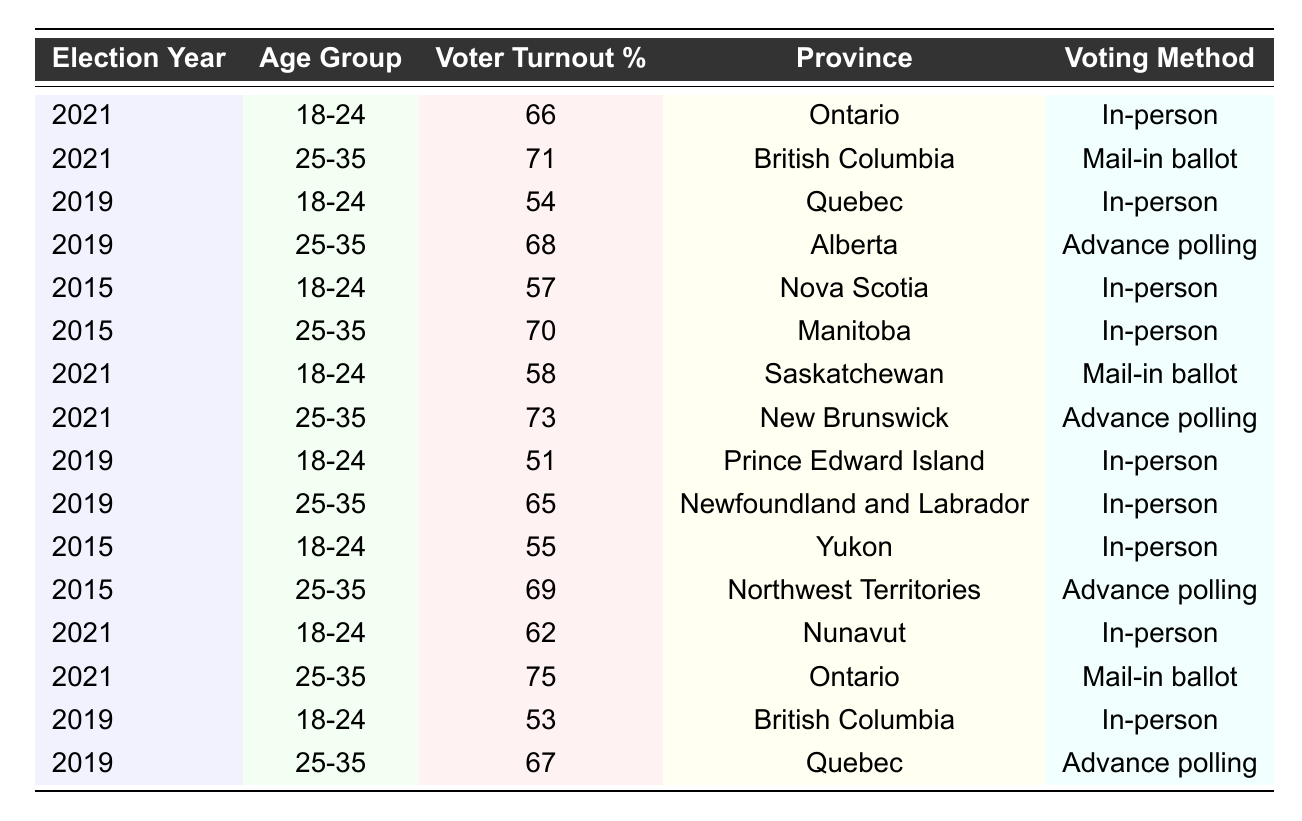What was the voter turnout percentage for 18-24-year-olds in Ontario in 2021? In 2021, the table shows that the voter turnout percentage for the age group 18-24 in Ontario was 66%.
Answer: 66% What voting method did 25-35-year-olds in British Columbia use in the 2021 election? According to the table, 25-35-year-olds in British Columbia voted by mail-in ballot in 2021.
Answer: Mail-in ballot What is the average voter turnout percentage for 18-24-year-olds in all provinces across the elections in 2015, 2019, and 2021? Adding the voter turnout percentages for 18-24-year-olds from 2015 (57), 2019 (54), and 2021 (66), we get 57 + 54 + 66 = 177. Then dividing by the number of data points (3), the average is 177/3 = 59.
Answer: 59 Which age group had the highest voter turnout in the 2021 election, and what was the percentage? Observing the 2021 data, the age group 25-35 in Ontario had the highest turnout at 75%. Checking all entries for 2021 confirms this is the highest percentage across age groups.
Answer: 75% Is it true that voter turnout for 18-24-year-olds decreased from 2019 to 2021 in Prince Edward Island? In 2019, the voter turnout was 51% for 18-24-year-olds in Prince Edward Island, and in 2021 it is not listed, which means it cannot be compared directly. However, the turnout was not documented for 2021 in that province, indicating a lack of data. Thus, we cannot conclude a decrease.
Answer: No What was the voter turnout percentage for 25-35-year-olds in Alberta in the 2019 election? The table shows that for 25-35-year-olds in Alberta during the 2019 election, the voter turnout percentage was 68%.
Answer: 68% Which province had the lowest voter turnout for 18-24-year-olds in the 2019 election? The lowest turnout for the 18-24 age group in 2019 is found in Prince Edward Island at 51%, as the table lists it clearly.
Answer: Prince Edward Island Compared to 2019, did the voter turnout for 25-35-year-olds increase in the 2021 election in New Brunswick? In 2019, the voter turnout for 25-35-year-olds in New Brunswick is not provided but according to the 2021 data, it was 73%. Since no previous data exists to compare, we cannot conclusively say it increased or decreased.
Answer: Cannot determine What voting method was used by the most provinces for the 25-35 age group in the 2021 elections? In 2021 for the 25-35 age group, two provinces used advance polling (New Brunswick) and mail-in ballots (Ontario). Since both methods are used, it indicates a split between methods, making it impossible to determine a single most common method.
Answer: No clear majority method What was the trend in voter turnout percentages for the age group 18-24 from 2015 to 2021? For the years provided: 2015 was 57%, 2019 was 54%, and 2021 was 66%. The trend shows a decrease from 2015 to 2019 but then an increase in 2021, resulting in a final upward trend over the full period.
Answer: Upward trend overall 